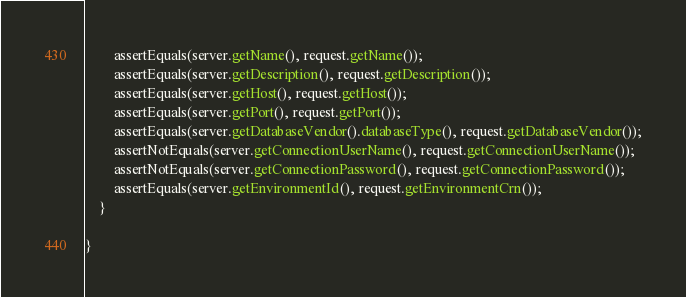<code> <loc_0><loc_0><loc_500><loc_500><_Java_>
        assertEquals(server.getName(), request.getName());
        assertEquals(server.getDescription(), request.getDescription());
        assertEquals(server.getHost(), request.getHost());
        assertEquals(server.getPort(), request.getPort());
        assertEquals(server.getDatabaseVendor().databaseType(), request.getDatabaseVendor());
        assertNotEquals(server.getConnectionUserName(), request.getConnectionUserName());
        assertNotEquals(server.getConnectionPassword(), request.getConnectionPassword());
        assertEquals(server.getEnvironmentId(), request.getEnvironmentCrn());
    }

}
</code> 